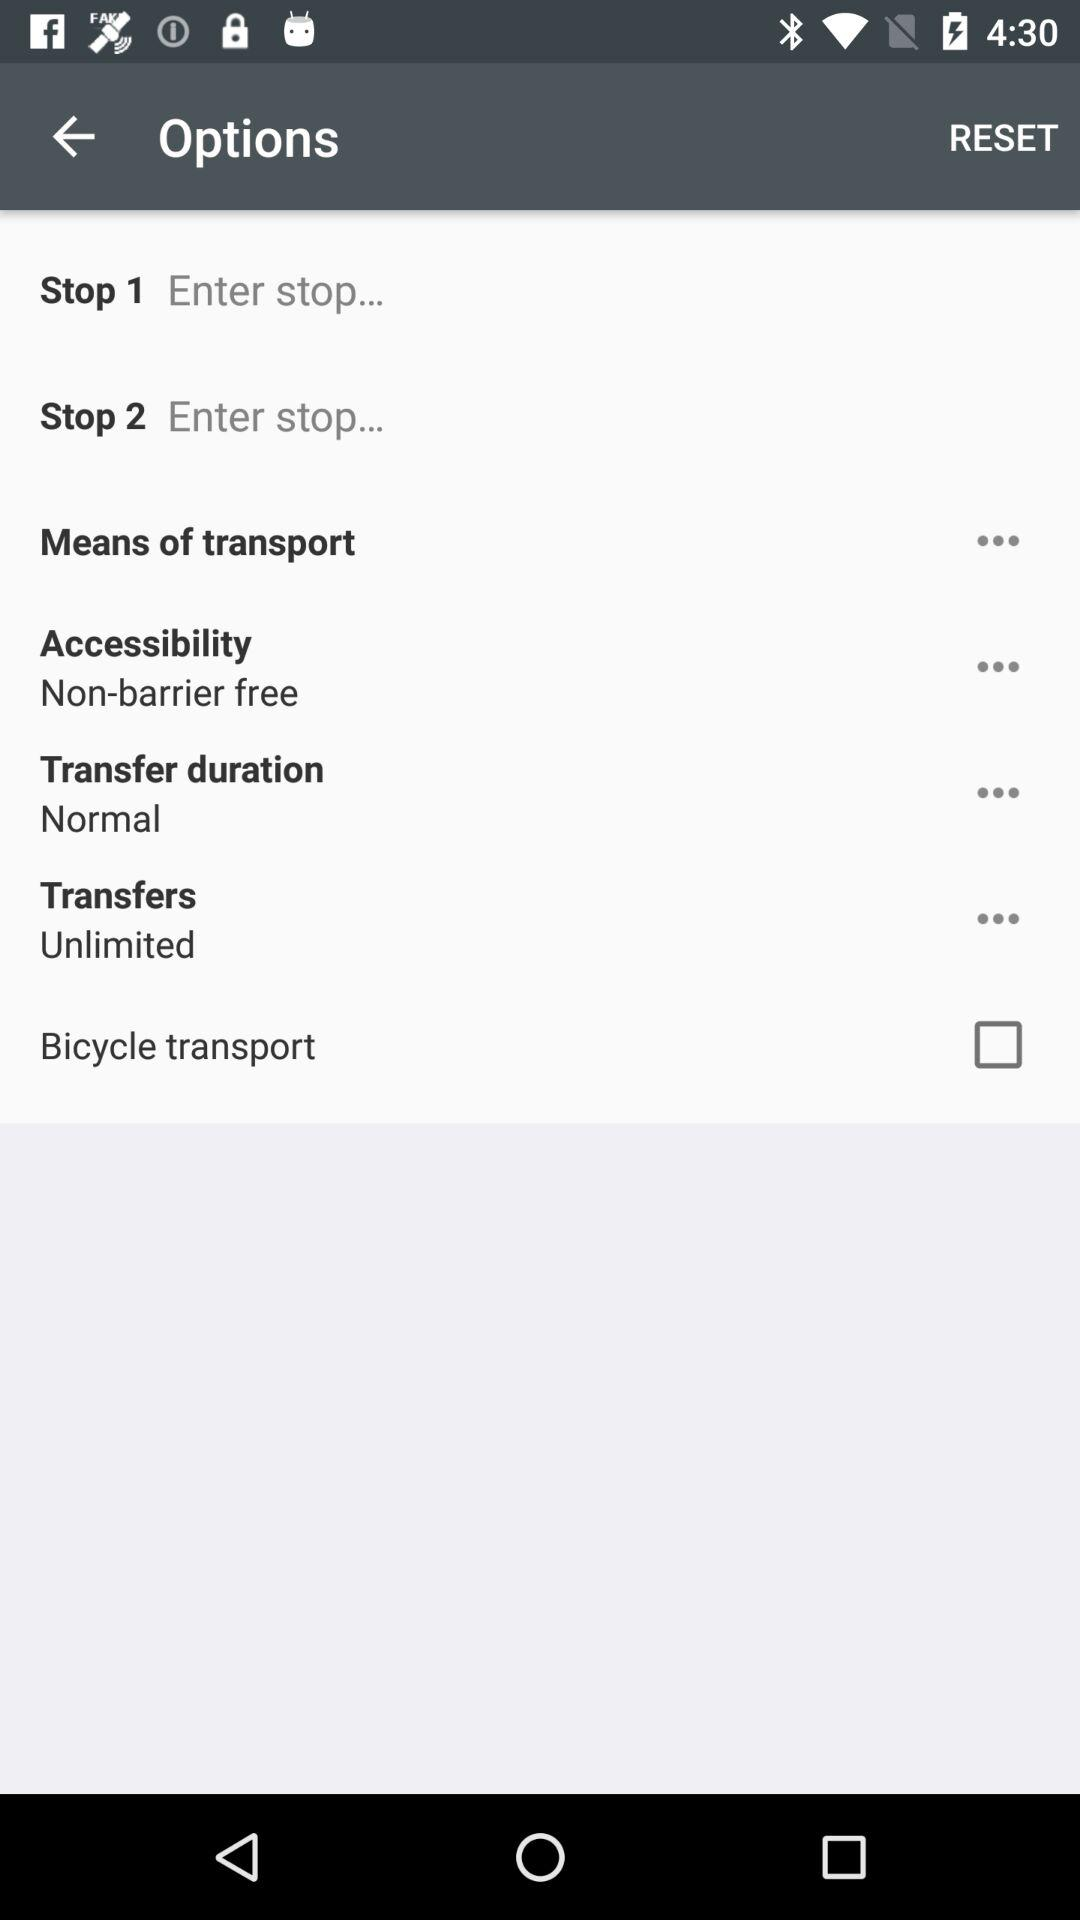What is the status of bicycle transport? The status is off. 